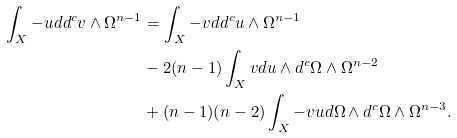Convert formula to latex. <formula><loc_0><loc_0><loc_500><loc_500>\int _ { X } - u d d ^ { c } v \wedge \Omega ^ { n - 1 } & = \int _ { X } - v d d ^ { c } u \wedge \Omega ^ { n - 1 } \\ & - 2 ( n - 1 ) \int _ { X } v d u \wedge d ^ { c } \Omega \wedge \Omega ^ { n - 2 } \\ & + ( n - 1 ) ( n - 2 ) \int _ { X } - v u d \Omega \wedge d ^ { c } \Omega \wedge \Omega ^ { n - 3 } .</formula> 